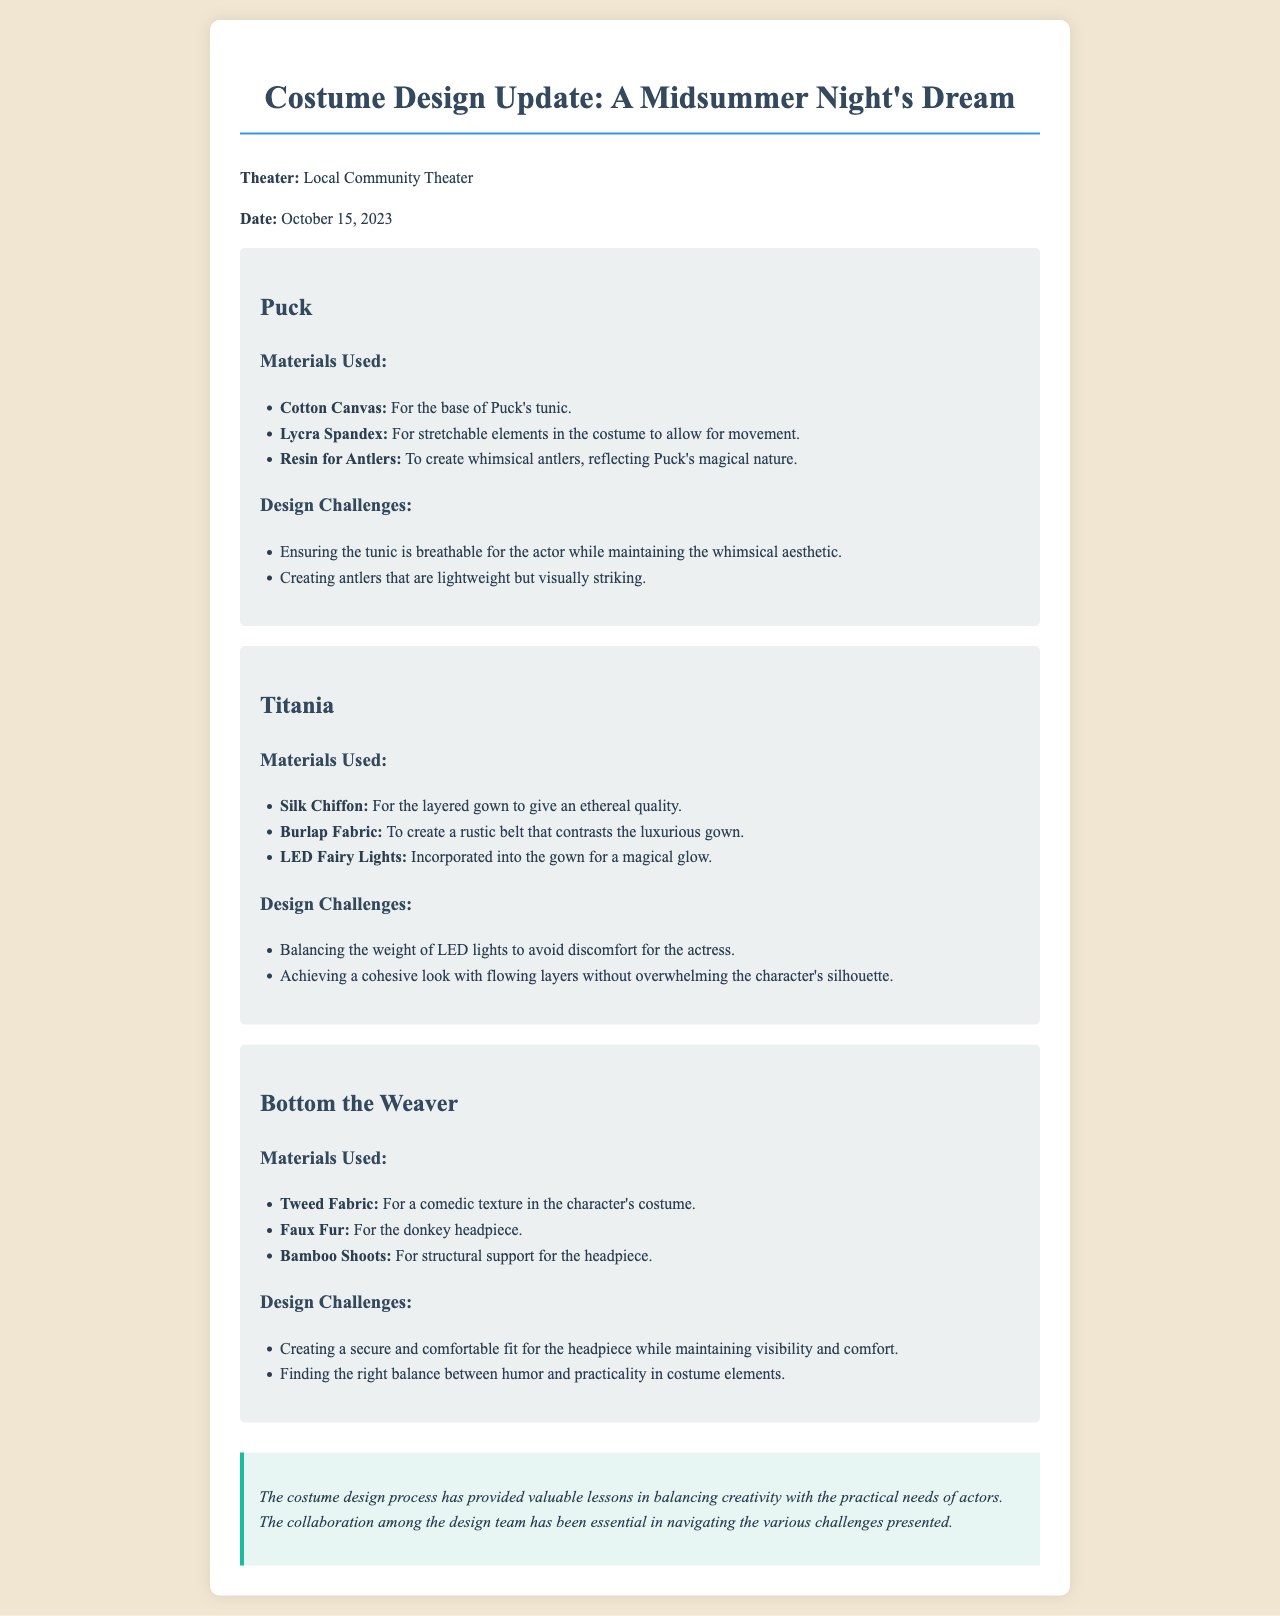What is the title of the production? The title of the production is explicitly mentioned in the document header as "A Midsummer Night's Dream."
Answer: A Midsummer Night's Dream What date was the update written? The date of the update is provided in the document as "October 15, 2023."
Answer: October 15, 2023 What material is used for Puck's tunic? The document specifies that "Cotton Canvas" is used for the base of Puck's tunic.
Answer: Cotton Canvas What challenge did the design team face with Titania's costume? One of the challenges mentioned for Titania’s costume is "Balancing the weight of LED lights to avoid discomfort for the actress."
Answer: Balancing the weight of LED lights What material is used for Bottom the Weaver's donkey headpiece? The document states that "Faux Fur" is used for the donkey headpiece.
Answer: Faux Fur How many characters have their costumes detailed in the update? The document details costumes for three characters: Puck, Titania, and Bottom the Weaver.
Answer: Three What lighting element is included in Titania's gown? The update mentions that "LED Fairy Lights" are incorporated into Titania's gown.
Answer: LED Fairy Lights What type of fabric is used for Bottom's costume? The material for Bottom's costume is specified as "Tweed Fabric."
Answer: Tweed Fabric What is emphasized as essential in the design process? The document suggests that "collaboration among the design team" is essential in the process.
Answer: Collaboration among the design team 